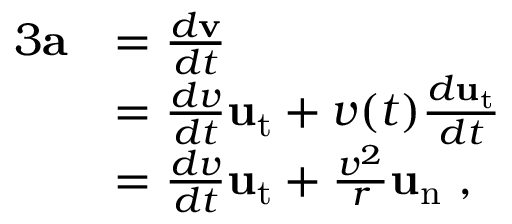Convert formula to latex. <formula><loc_0><loc_0><loc_500><loc_500>{ \begin{array} { r l } { { 3 } a } & { = { \frac { d v } { d t } } } \\ & { = { \frac { d v } { d t } } u _ { t } + v ( t ) { \frac { d u _ { t } } { d t } } } \\ & { = { \frac { d v } { d t } } u _ { t } + { \frac { v ^ { 2 } } { r } } u _ { n } \ , } \end{array} }</formula> 